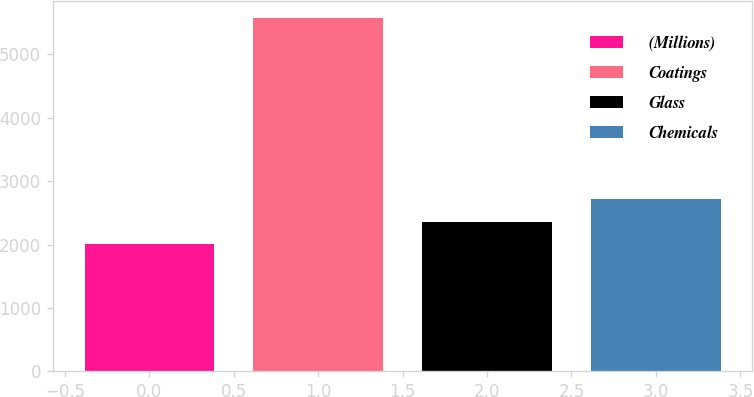Convert chart. <chart><loc_0><loc_0><loc_500><loc_500><bar_chart><fcel>(Millions)<fcel>Coatings<fcel>Glass<fcel>Chemicals<nl><fcel>2005<fcel>5566<fcel>2361.1<fcel>2717.2<nl></chart> 